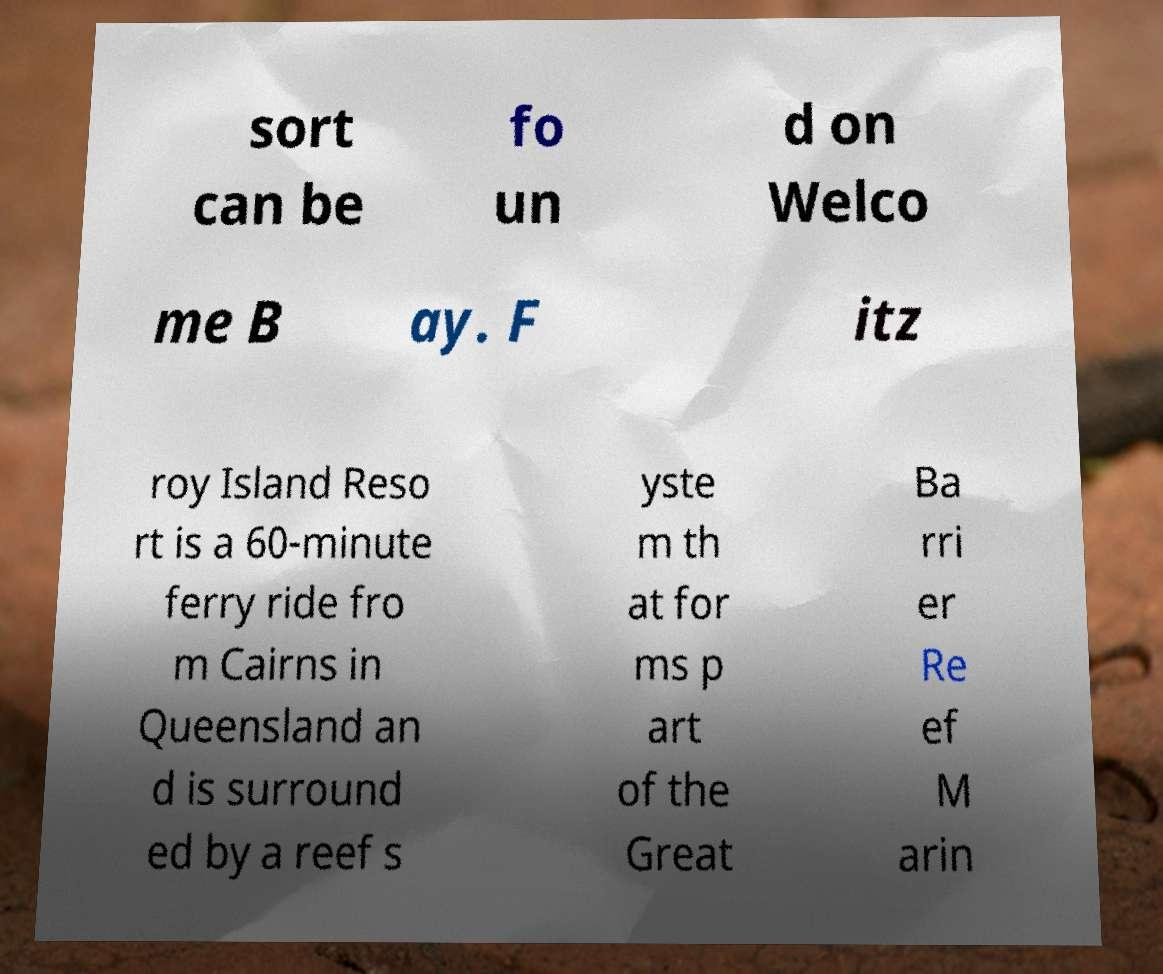Could you assist in decoding the text presented in this image and type it out clearly? sort can be fo un d on Welco me B ay. F itz roy Island Reso rt is a 60-minute ferry ride fro m Cairns in Queensland an d is surround ed by a reef s yste m th at for ms p art of the Great Ba rri er Re ef M arin 